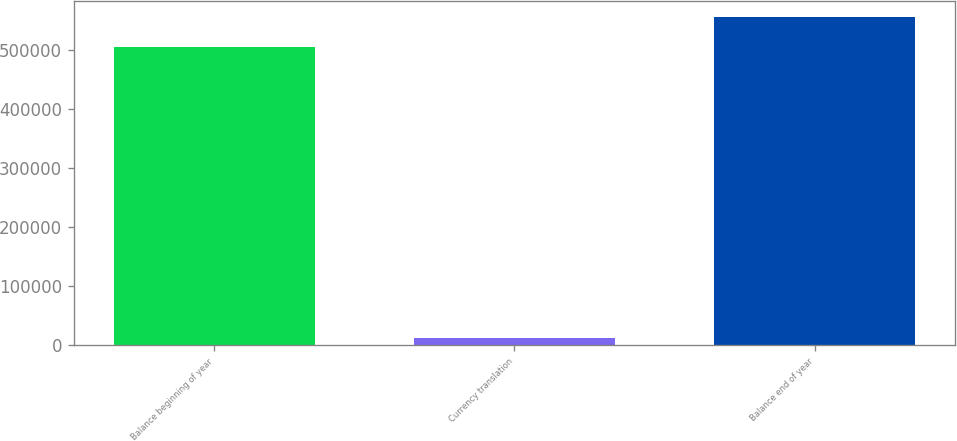Convert chart. <chart><loc_0><loc_0><loc_500><loc_500><bar_chart><fcel>Balance beginning of year<fcel>Currency translation<fcel>Balance end of year<nl><fcel>504784<fcel>13426<fcel>555709<nl></chart> 